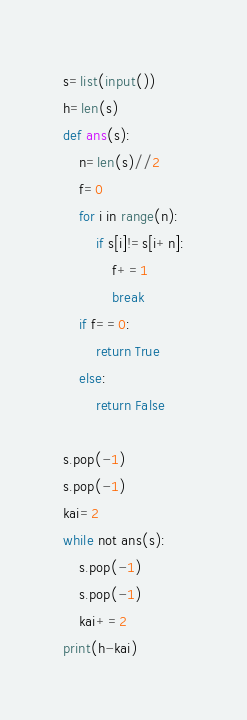Convert code to text. <code><loc_0><loc_0><loc_500><loc_500><_Python_>s=list(input())
h=len(s)
def ans(s):
    n=len(s)//2
    f=0
    for i in range(n):
        if s[i]!=s[i+n]:
            f+=1
            break
    if f==0:
        return True
    else:
        return False
      
s.pop(-1)
s.pop(-1)
kai=2
while not ans(s):
    s.pop(-1)
    s.pop(-1)
    kai+=2
print(h-kai)</code> 